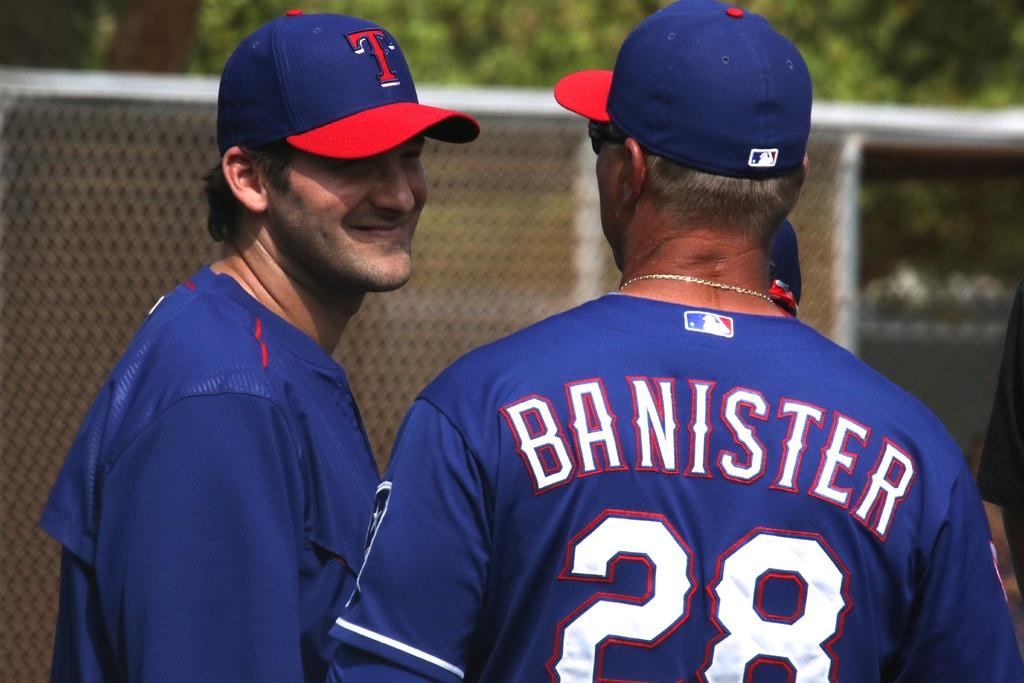Provide a one-sentence caption for the provided image. Two baseball players talk to eachother, Banister is talking to his teammate. 